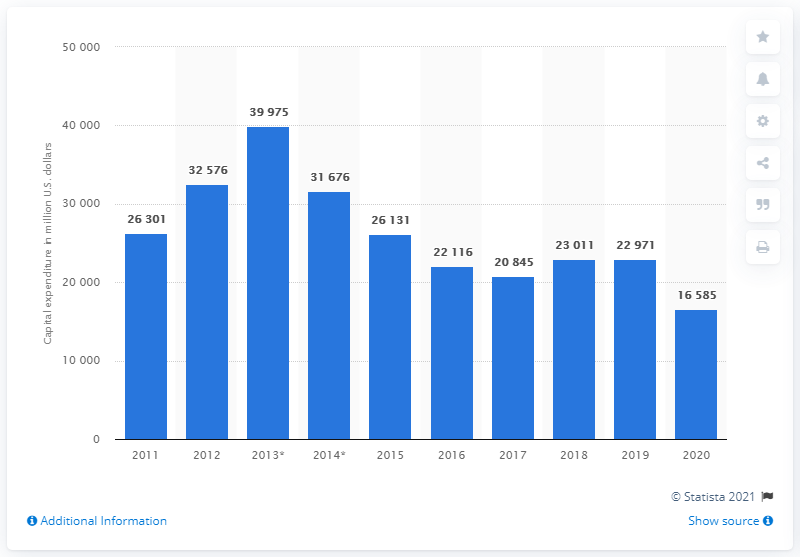List a handful of essential elements in this visual. In 2020, Royal Dutch Shell invested a significant amount of money, approximately 16,585, in capital projects. 